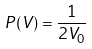<formula> <loc_0><loc_0><loc_500><loc_500>P ( V ) = \frac { 1 } { 2 V _ { 0 } }</formula> 